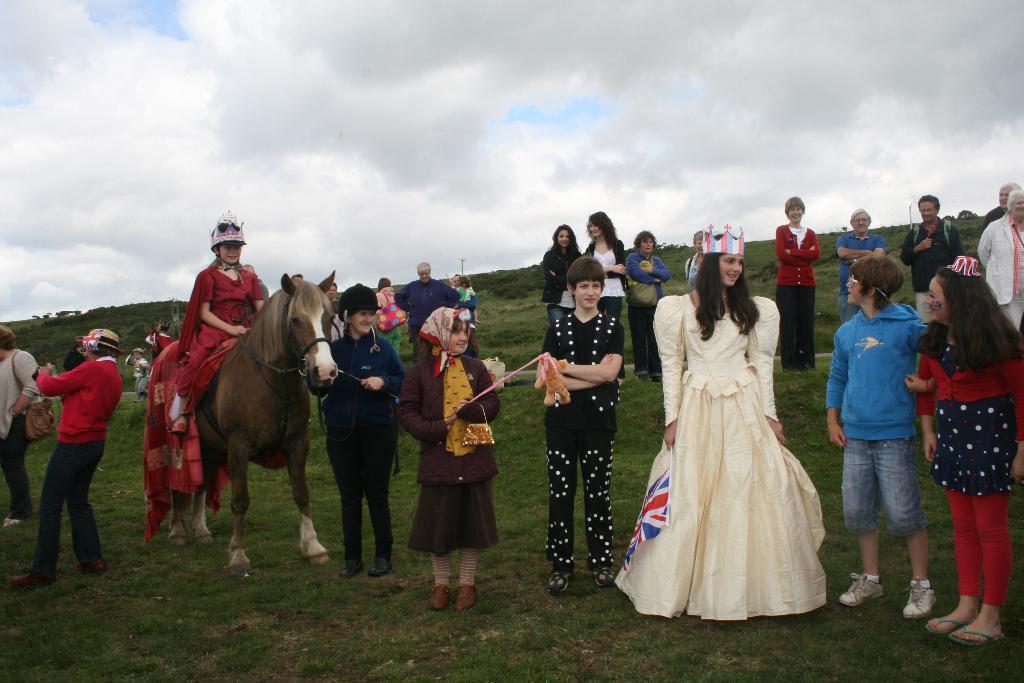In one or two sentences, can you explain what this image depicts? In this image there are a group of people who are standing. On the left side there is one horse and on that horse there is one girl who is sitting and on the background there is a sky and in the bottom there is a grass. 